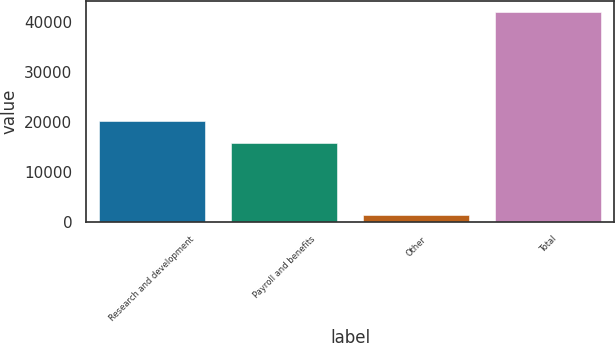Convert chart to OTSL. <chart><loc_0><loc_0><loc_500><loc_500><bar_chart><fcel>Research and development<fcel>Payroll and benefits<fcel>Other<fcel>Total<nl><fcel>20098<fcel>15832<fcel>1315<fcel>42061<nl></chart> 